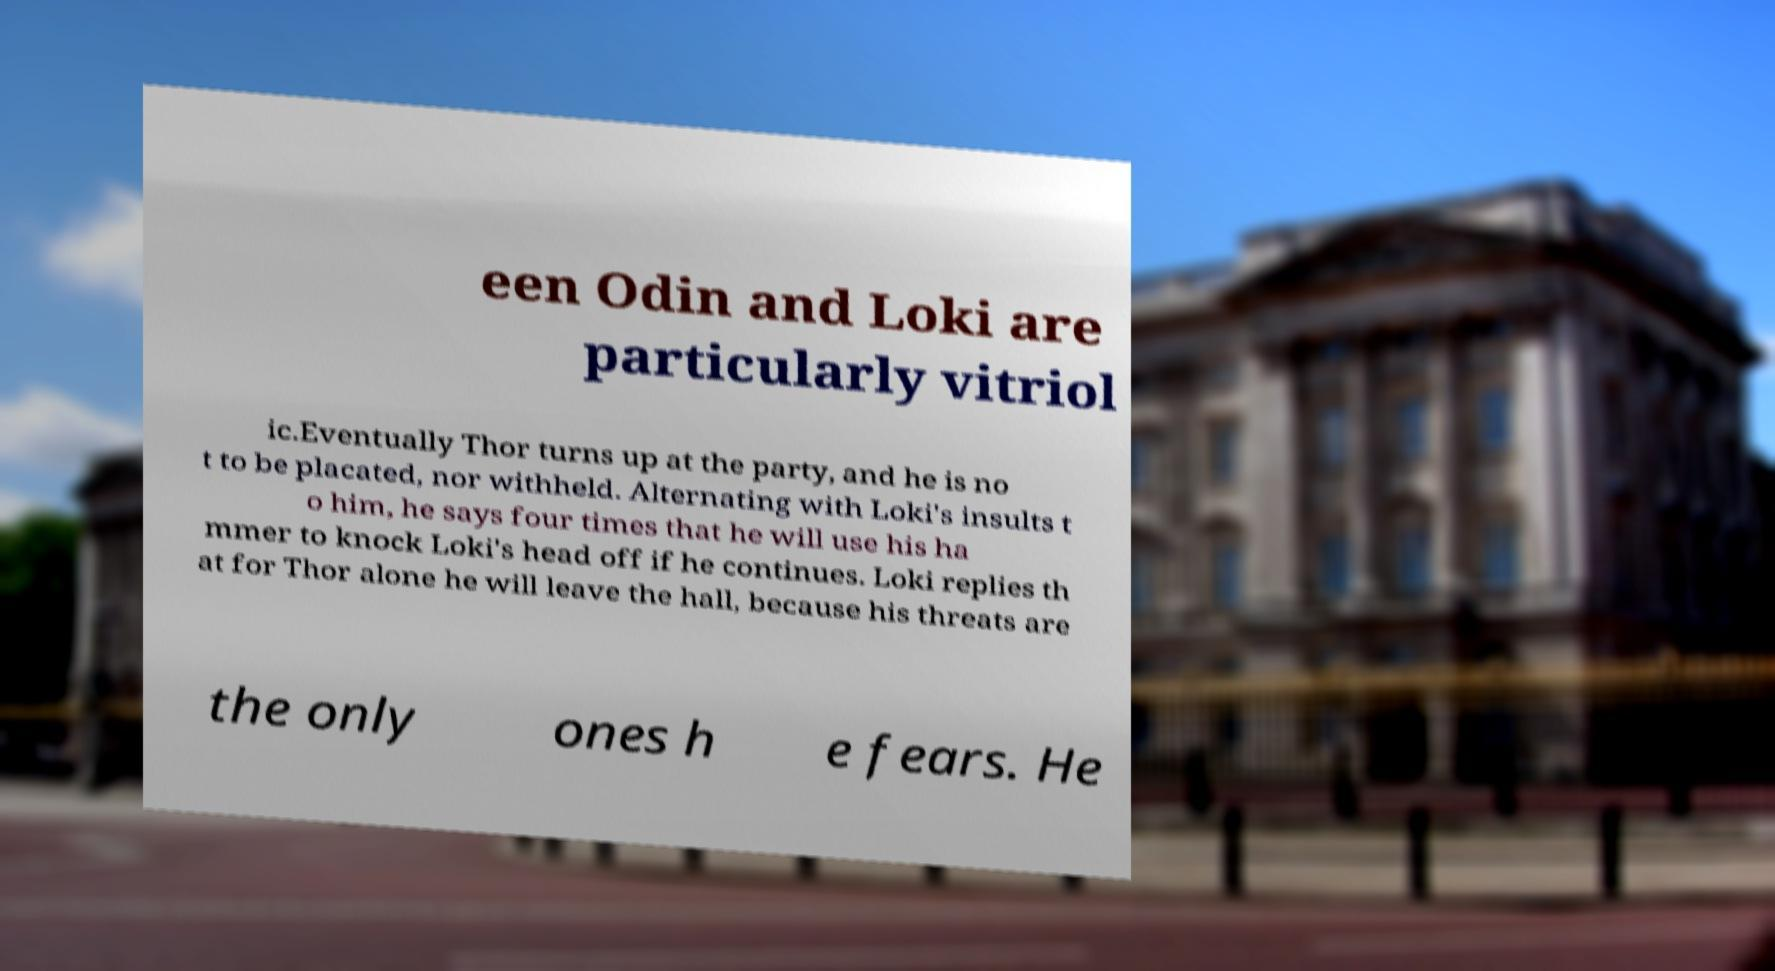There's text embedded in this image that I need extracted. Can you transcribe it verbatim? een Odin and Loki are particularly vitriol ic.Eventually Thor turns up at the party, and he is no t to be placated, nor withheld. Alternating with Loki's insults t o him, he says four times that he will use his ha mmer to knock Loki's head off if he continues. Loki replies th at for Thor alone he will leave the hall, because his threats are the only ones h e fears. He 